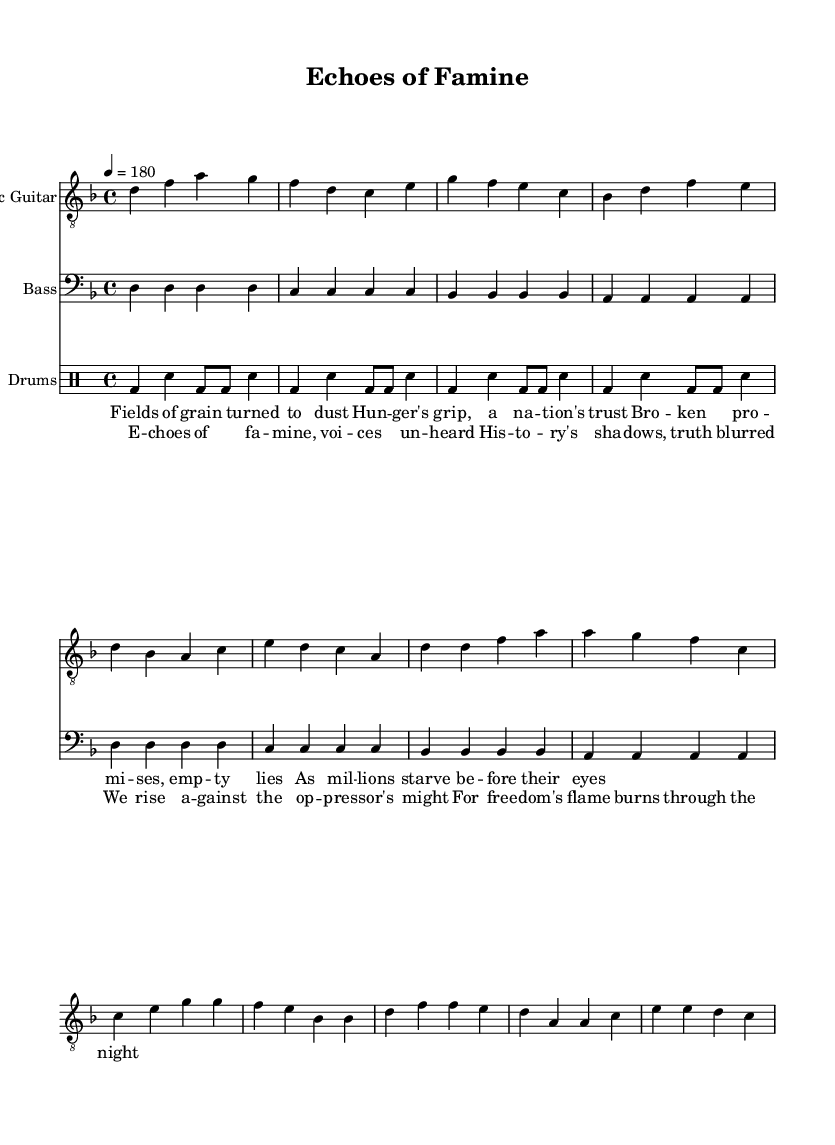What is the key signature of this music? The key signature is represented at the beginning of the music and indicates D minor, which has one flat (B flat).
Answer: D minor What is the time signature of this music? The time signature is shown at the beginning of the score and is 4/4, indicating that there are four beats in each measure and the quarter note gets one beat.
Answer: 4/4 What is the tempo marking of the piece? The tempo marking is indicated as 4 = 180, meaning there are 180 beats per minute, providing a reference for how fast the music should be played.
Answer: 180 How many measures are in the verse section? By counting the number of groups of notes in the section labeled for the verse, there are four measures of music present, each containing four beats.
Answer: 4 What instruments are represented in this sheet music? There are three instruments present: electric guitar, bass guitar, and drums, each clearly labeled at the start of their respective staves.
Answer: Electric guitar, bass, drums What is the main theme of the lyrics in the chorus? The chorus lyrics express themes of resistance and the fight for freedom, indicating a collective struggle against oppression with imagery of darkness and fire.
Answer: Resistance and freedom How does the punk style influence the structure of the song? The punk style is reflected in the fast tempo, simple chord progressions, and strong rhythmic emphasis, all characteristics typical of punk music aimed at conveying energy and urgency.
Answer: Fast tempo, strong rhythm 